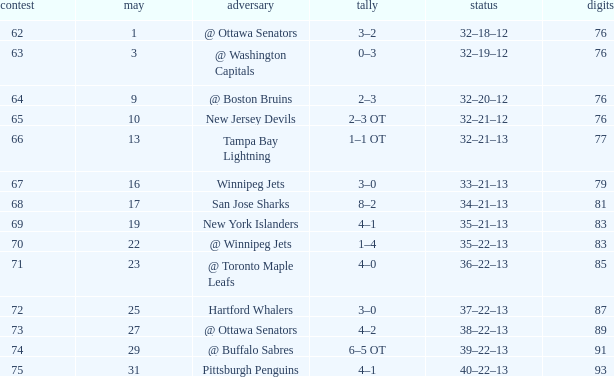How much March has Points of 85? 1.0. 